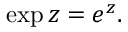Convert formula to latex. <formula><loc_0><loc_0><loc_500><loc_500>\exp z = e ^ { z } .</formula> 